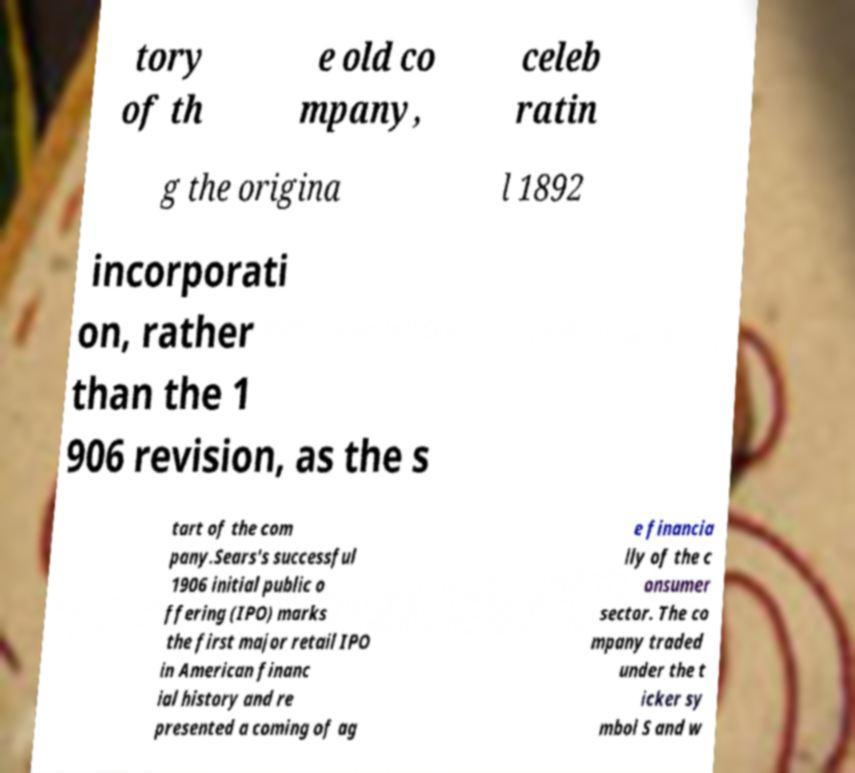Could you assist in decoding the text presented in this image and type it out clearly? tory of th e old co mpany, celeb ratin g the origina l 1892 incorporati on, rather than the 1 906 revision, as the s tart of the com pany.Sears's successful 1906 initial public o ffering (IPO) marks the first major retail IPO in American financ ial history and re presented a coming of ag e financia lly of the c onsumer sector. The co mpany traded under the t icker sy mbol S and w 